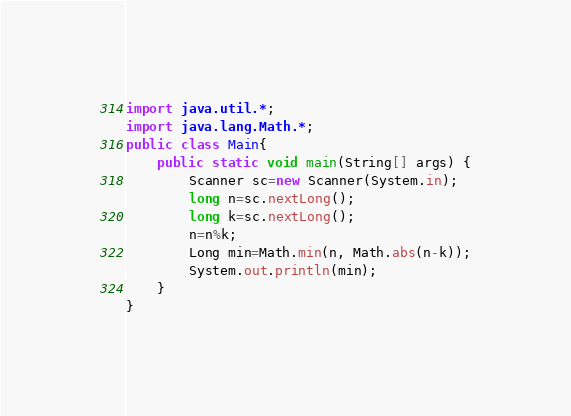<code> <loc_0><loc_0><loc_500><loc_500><_Java_>import java.util.*;
import java.lang.Math.*;
public class Main{
	public static void main(String[] args) {
		Scanner sc=new Scanner(System.in);
		long n=sc.nextLong();
		long k=sc.nextLong();
		n=n%k;
		Long min=Math.min(n, Math.abs(n-k));
		System.out.println(min);
	}
}</code> 